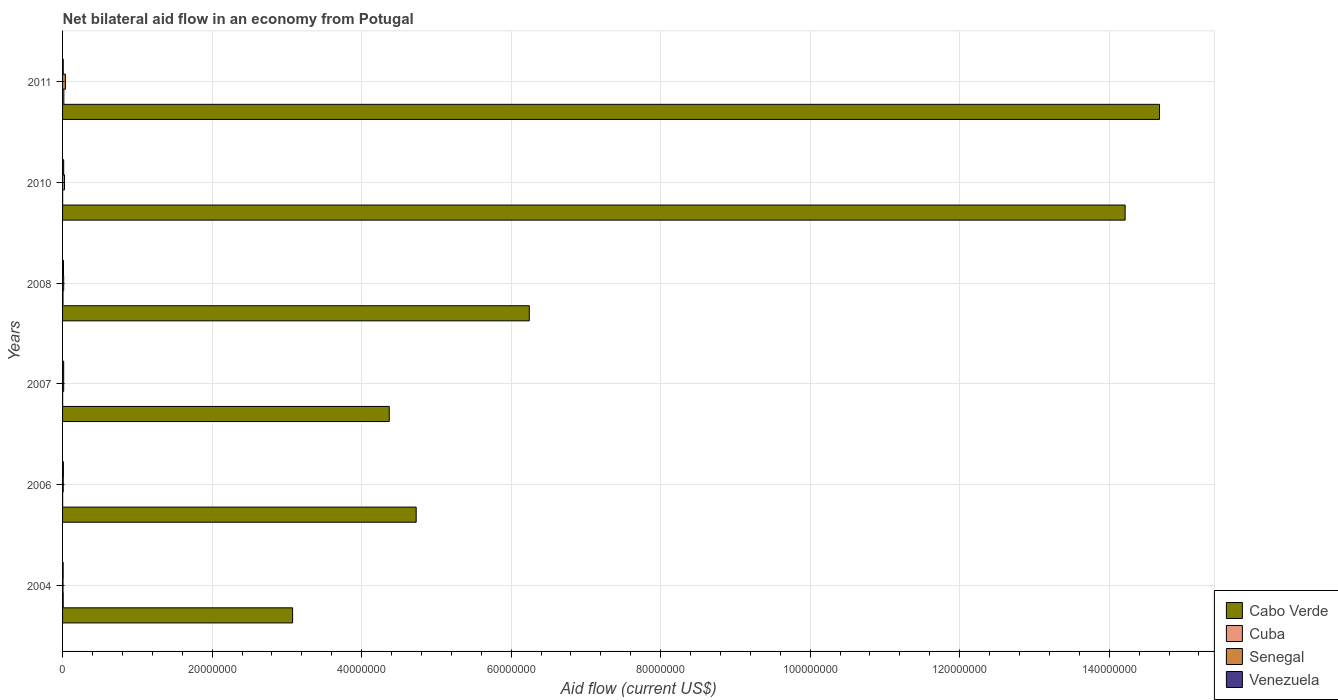Are the number of bars per tick equal to the number of legend labels?
Offer a very short reply. Yes. How many bars are there on the 5th tick from the bottom?
Your answer should be very brief. 4. What is the label of the 5th group of bars from the top?
Offer a terse response. 2006. Across all years, what is the minimum net bilateral aid flow in Cuba?
Offer a very short reply. 10000. What is the total net bilateral aid flow in Cabo Verde in the graph?
Offer a terse response. 4.73e+08. What is the difference between the net bilateral aid flow in Cabo Verde in 2011 and the net bilateral aid flow in Cuba in 2008?
Your answer should be compact. 1.47e+08. What is the average net bilateral aid flow in Cabo Verde per year?
Your response must be concise. 7.88e+07. In the year 2008, what is the difference between the net bilateral aid flow in Cabo Verde and net bilateral aid flow in Senegal?
Ensure brevity in your answer.  6.23e+07. What is the ratio of the net bilateral aid flow in Cuba in 2008 to that in 2011?
Your answer should be very brief. 0.35. What is the difference between the highest and the lowest net bilateral aid flow in Cabo Verde?
Offer a very short reply. 1.16e+08. Is it the case that in every year, the sum of the net bilateral aid flow in Senegal and net bilateral aid flow in Cuba is greater than the sum of net bilateral aid flow in Venezuela and net bilateral aid flow in Cabo Verde?
Make the answer very short. No. What does the 1st bar from the top in 2004 represents?
Give a very brief answer. Venezuela. What does the 3rd bar from the bottom in 2010 represents?
Ensure brevity in your answer.  Senegal. Are all the bars in the graph horizontal?
Provide a succinct answer. Yes. What is the difference between two consecutive major ticks on the X-axis?
Your answer should be very brief. 2.00e+07. Does the graph contain any zero values?
Offer a very short reply. No. Where does the legend appear in the graph?
Your answer should be very brief. Bottom right. What is the title of the graph?
Offer a very short reply. Net bilateral aid flow in an economy from Potugal. What is the label or title of the X-axis?
Your answer should be compact. Aid flow (current US$). What is the Aid flow (current US$) in Cabo Verde in 2004?
Ensure brevity in your answer.  3.08e+07. What is the Aid flow (current US$) of Cuba in 2004?
Offer a very short reply. 9.00e+04. What is the Aid flow (current US$) in Senegal in 2004?
Your response must be concise. 6.00e+04. What is the Aid flow (current US$) of Cabo Verde in 2006?
Offer a very short reply. 4.73e+07. What is the Aid flow (current US$) of Cabo Verde in 2007?
Offer a terse response. 4.37e+07. What is the Aid flow (current US$) of Cuba in 2007?
Provide a succinct answer. 10000. What is the Aid flow (current US$) of Senegal in 2007?
Ensure brevity in your answer.  1.50e+05. What is the Aid flow (current US$) in Cabo Verde in 2008?
Your answer should be compact. 6.24e+07. What is the Aid flow (current US$) in Cuba in 2008?
Your answer should be very brief. 6.00e+04. What is the Aid flow (current US$) in Venezuela in 2008?
Offer a very short reply. 1.20e+05. What is the Aid flow (current US$) in Cabo Verde in 2010?
Keep it short and to the point. 1.42e+08. What is the Aid flow (current US$) in Cuba in 2010?
Ensure brevity in your answer.  10000. What is the Aid flow (current US$) in Venezuela in 2010?
Give a very brief answer. 1.50e+05. What is the Aid flow (current US$) in Cabo Verde in 2011?
Offer a very short reply. 1.47e+08. What is the Aid flow (current US$) in Cuba in 2011?
Keep it short and to the point. 1.70e+05. What is the Aid flow (current US$) in Senegal in 2011?
Provide a succinct answer. 3.80e+05. Across all years, what is the maximum Aid flow (current US$) in Cabo Verde?
Give a very brief answer. 1.47e+08. Across all years, what is the maximum Aid flow (current US$) in Cuba?
Your answer should be compact. 1.70e+05. Across all years, what is the maximum Aid flow (current US$) of Senegal?
Your answer should be very brief. 3.80e+05. Across all years, what is the maximum Aid flow (current US$) of Venezuela?
Your response must be concise. 1.50e+05. Across all years, what is the minimum Aid flow (current US$) in Cabo Verde?
Make the answer very short. 3.08e+07. Across all years, what is the minimum Aid flow (current US$) of Senegal?
Your answer should be very brief. 6.00e+04. What is the total Aid flow (current US$) of Cabo Verde in the graph?
Provide a succinct answer. 4.73e+08. What is the total Aid flow (current US$) in Senegal in the graph?
Keep it short and to the point. 1.09e+06. What is the total Aid flow (current US$) of Venezuela in the graph?
Provide a short and direct response. 7.00e+05. What is the difference between the Aid flow (current US$) of Cabo Verde in 2004 and that in 2006?
Your answer should be very brief. -1.65e+07. What is the difference between the Aid flow (current US$) of Venezuela in 2004 and that in 2006?
Ensure brevity in your answer.  -3.00e+04. What is the difference between the Aid flow (current US$) in Cabo Verde in 2004 and that in 2007?
Offer a terse response. -1.29e+07. What is the difference between the Aid flow (current US$) of Venezuela in 2004 and that in 2007?
Provide a short and direct response. -7.00e+04. What is the difference between the Aid flow (current US$) of Cabo Verde in 2004 and that in 2008?
Your answer should be very brief. -3.17e+07. What is the difference between the Aid flow (current US$) in Cabo Verde in 2004 and that in 2010?
Offer a terse response. -1.11e+08. What is the difference between the Aid flow (current US$) in Cuba in 2004 and that in 2010?
Provide a short and direct response. 8.00e+04. What is the difference between the Aid flow (current US$) of Senegal in 2004 and that in 2010?
Provide a succinct answer. -2.00e+05. What is the difference between the Aid flow (current US$) in Venezuela in 2004 and that in 2010?
Offer a very short reply. -7.00e+04. What is the difference between the Aid flow (current US$) of Cabo Verde in 2004 and that in 2011?
Give a very brief answer. -1.16e+08. What is the difference between the Aid flow (current US$) in Senegal in 2004 and that in 2011?
Give a very brief answer. -3.20e+05. What is the difference between the Aid flow (current US$) in Venezuela in 2004 and that in 2011?
Provide a short and direct response. -10000. What is the difference between the Aid flow (current US$) of Cabo Verde in 2006 and that in 2007?
Provide a short and direct response. 3.60e+06. What is the difference between the Aid flow (current US$) of Senegal in 2006 and that in 2007?
Offer a very short reply. -6.00e+04. What is the difference between the Aid flow (current US$) of Cabo Verde in 2006 and that in 2008?
Give a very brief answer. -1.51e+07. What is the difference between the Aid flow (current US$) in Venezuela in 2006 and that in 2008?
Ensure brevity in your answer.  -10000. What is the difference between the Aid flow (current US$) in Cabo Verde in 2006 and that in 2010?
Offer a very short reply. -9.48e+07. What is the difference between the Aid flow (current US$) in Senegal in 2006 and that in 2010?
Ensure brevity in your answer.  -1.70e+05. What is the difference between the Aid flow (current US$) of Cabo Verde in 2006 and that in 2011?
Your answer should be very brief. -9.94e+07. What is the difference between the Aid flow (current US$) in Cuba in 2006 and that in 2011?
Ensure brevity in your answer.  -1.60e+05. What is the difference between the Aid flow (current US$) of Venezuela in 2006 and that in 2011?
Ensure brevity in your answer.  2.00e+04. What is the difference between the Aid flow (current US$) of Cabo Verde in 2007 and that in 2008?
Make the answer very short. -1.87e+07. What is the difference between the Aid flow (current US$) of Senegal in 2007 and that in 2008?
Offer a very short reply. 0. What is the difference between the Aid flow (current US$) in Cabo Verde in 2007 and that in 2010?
Provide a succinct answer. -9.84e+07. What is the difference between the Aid flow (current US$) of Cuba in 2007 and that in 2010?
Ensure brevity in your answer.  0. What is the difference between the Aid flow (current US$) in Senegal in 2007 and that in 2010?
Your response must be concise. -1.10e+05. What is the difference between the Aid flow (current US$) in Cabo Verde in 2007 and that in 2011?
Provide a short and direct response. -1.03e+08. What is the difference between the Aid flow (current US$) in Cuba in 2007 and that in 2011?
Give a very brief answer. -1.60e+05. What is the difference between the Aid flow (current US$) of Senegal in 2007 and that in 2011?
Keep it short and to the point. -2.30e+05. What is the difference between the Aid flow (current US$) of Venezuela in 2007 and that in 2011?
Offer a terse response. 6.00e+04. What is the difference between the Aid flow (current US$) of Cabo Verde in 2008 and that in 2010?
Your answer should be very brief. -7.97e+07. What is the difference between the Aid flow (current US$) in Venezuela in 2008 and that in 2010?
Provide a short and direct response. -3.00e+04. What is the difference between the Aid flow (current US$) of Cabo Verde in 2008 and that in 2011?
Give a very brief answer. -8.43e+07. What is the difference between the Aid flow (current US$) of Cuba in 2008 and that in 2011?
Offer a very short reply. -1.10e+05. What is the difference between the Aid flow (current US$) of Cabo Verde in 2010 and that in 2011?
Ensure brevity in your answer.  -4.60e+06. What is the difference between the Aid flow (current US$) in Cuba in 2010 and that in 2011?
Your answer should be compact. -1.60e+05. What is the difference between the Aid flow (current US$) of Venezuela in 2010 and that in 2011?
Ensure brevity in your answer.  6.00e+04. What is the difference between the Aid flow (current US$) of Cabo Verde in 2004 and the Aid flow (current US$) of Cuba in 2006?
Your response must be concise. 3.08e+07. What is the difference between the Aid flow (current US$) in Cabo Verde in 2004 and the Aid flow (current US$) in Senegal in 2006?
Provide a succinct answer. 3.07e+07. What is the difference between the Aid flow (current US$) in Cabo Verde in 2004 and the Aid flow (current US$) in Venezuela in 2006?
Give a very brief answer. 3.07e+07. What is the difference between the Aid flow (current US$) of Cuba in 2004 and the Aid flow (current US$) of Senegal in 2006?
Provide a short and direct response. 0. What is the difference between the Aid flow (current US$) in Senegal in 2004 and the Aid flow (current US$) in Venezuela in 2006?
Give a very brief answer. -5.00e+04. What is the difference between the Aid flow (current US$) of Cabo Verde in 2004 and the Aid flow (current US$) of Cuba in 2007?
Provide a succinct answer. 3.08e+07. What is the difference between the Aid flow (current US$) of Cabo Verde in 2004 and the Aid flow (current US$) of Senegal in 2007?
Your response must be concise. 3.06e+07. What is the difference between the Aid flow (current US$) of Cabo Verde in 2004 and the Aid flow (current US$) of Venezuela in 2007?
Your response must be concise. 3.06e+07. What is the difference between the Aid flow (current US$) of Cuba in 2004 and the Aid flow (current US$) of Senegal in 2007?
Provide a short and direct response. -6.00e+04. What is the difference between the Aid flow (current US$) of Senegal in 2004 and the Aid flow (current US$) of Venezuela in 2007?
Provide a succinct answer. -9.00e+04. What is the difference between the Aid flow (current US$) of Cabo Verde in 2004 and the Aid flow (current US$) of Cuba in 2008?
Your answer should be compact. 3.07e+07. What is the difference between the Aid flow (current US$) of Cabo Verde in 2004 and the Aid flow (current US$) of Senegal in 2008?
Ensure brevity in your answer.  3.06e+07. What is the difference between the Aid flow (current US$) of Cabo Verde in 2004 and the Aid flow (current US$) of Venezuela in 2008?
Ensure brevity in your answer.  3.06e+07. What is the difference between the Aid flow (current US$) of Cuba in 2004 and the Aid flow (current US$) of Venezuela in 2008?
Keep it short and to the point. -3.00e+04. What is the difference between the Aid flow (current US$) of Senegal in 2004 and the Aid flow (current US$) of Venezuela in 2008?
Offer a terse response. -6.00e+04. What is the difference between the Aid flow (current US$) in Cabo Verde in 2004 and the Aid flow (current US$) in Cuba in 2010?
Your response must be concise. 3.08e+07. What is the difference between the Aid flow (current US$) of Cabo Verde in 2004 and the Aid flow (current US$) of Senegal in 2010?
Provide a short and direct response. 3.05e+07. What is the difference between the Aid flow (current US$) of Cabo Verde in 2004 and the Aid flow (current US$) of Venezuela in 2010?
Give a very brief answer. 3.06e+07. What is the difference between the Aid flow (current US$) in Cuba in 2004 and the Aid flow (current US$) in Senegal in 2010?
Provide a short and direct response. -1.70e+05. What is the difference between the Aid flow (current US$) of Senegal in 2004 and the Aid flow (current US$) of Venezuela in 2010?
Make the answer very short. -9.00e+04. What is the difference between the Aid flow (current US$) in Cabo Verde in 2004 and the Aid flow (current US$) in Cuba in 2011?
Offer a very short reply. 3.06e+07. What is the difference between the Aid flow (current US$) in Cabo Verde in 2004 and the Aid flow (current US$) in Senegal in 2011?
Your answer should be compact. 3.04e+07. What is the difference between the Aid flow (current US$) of Cabo Verde in 2004 and the Aid flow (current US$) of Venezuela in 2011?
Provide a short and direct response. 3.07e+07. What is the difference between the Aid flow (current US$) in Cuba in 2004 and the Aid flow (current US$) in Senegal in 2011?
Give a very brief answer. -2.90e+05. What is the difference between the Aid flow (current US$) in Cabo Verde in 2006 and the Aid flow (current US$) in Cuba in 2007?
Your answer should be very brief. 4.73e+07. What is the difference between the Aid flow (current US$) of Cabo Verde in 2006 and the Aid flow (current US$) of Senegal in 2007?
Your answer should be compact. 4.72e+07. What is the difference between the Aid flow (current US$) in Cabo Verde in 2006 and the Aid flow (current US$) in Venezuela in 2007?
Give a very brief answer. 4.72e+07. What is the difference between the Aid flow (current US$) in Cuba in 2006 and the Aid flow (current US$) in Venezuela in 2007?
Make the answer very short. -1.40e+05. What is the difference between the Aid flow (current US$) in Cabo Verde in 2006 and the Aid flow (current US$) in Cuba in 2008?
Provide a succinct answer. 4.72e+07. What is the difference between the Aid flow (current US$) of Cabo Verde in 2006 and the Aid flow (current US$) of Senegal in 2008?
Provide a short and direct response. 4.72e+07. What is the difference between the Aid flow (current US$) in Cabo Verde in 2006 and the Aid flow (current US$) in Venezuela in 2008?
Your response must be concise. 4.72e+07. What is the difference between the Aid flow (current US$) of Cabo Verde in 2006 and the Aid flow (current US$) of Cuba in 2010?
Keep it short and to the point. 4.73e+07. What is the difference between the Aid flow (current US$) in Cabo Verde in 2006 and the Aid flow (current US$) in Senegal in 2010?
Keep it short and to the point. 4.70e+07. What is the difference between the Aid flow (current US$) of Cabo Verde in 2006 and the Aid flow (current US$) of Venezuela in 2010?
Provide a succinct answer. 4.72e+07. What is the difference between the Aid flow (current US$) of Cuba in 2006 and the Aid flow (current US$) of Senegal in 2010?
Ensure brevity in your answer.  -2.50e+05. What is the difference between the Aid flow (current US$) of Cuba in 2006 and the Aid flow (current US$) of Venezuela in 2010?
Give a very brief answer. -1.40e+05. What is the difference between the Aid flow (current US$) in Cabo Verde in 2006 and the Aid flow (current US$) in Cuba in 2011?
Keep it short and to the point. 4.71e+07. What is the difference between the Aid flow (current US$) of Cabo Verde in 2006 and the Aid flow (current US$) of Senegal in 2011?
Your response must be concise. 4.69e+07. What is the difference between the Aid flow (current US$) in Cabo Verde in 2006 and the Aid flow (current US$) in Venezuela in 2011?
Provide a succinct answer. 4.72e+07. What is the difference between the Aid flow (current US$) in Cuba in 2006 and the Aid flow (current US$) in Senegal in 2011?
Your answer should be compact. -3.70e+05. What is the difference between the Aid flow (current US$) of Cuba in 2006 and the Aid flow (current US$) of Venezuela in 2011?
Provide a succinct answer. -8.00e+04. What is the difference between the Aid flow (current US$) of Cabo Verde in 2007 and the Aid flow (current US$) of Cuba in 2008?
Provide a succinct answer. 4.36e+07. What is the difference between the Aid flow (current US$) of Cabo Verde in 2007 and the Aid flow (current US$) of Senegal in 2008?
Your answer should be very brief. 4.36e+07. What is the difference between the Aid flow (current US$) in Cabo Verde in 2007 and the Aid flow (current US$) in Venezuela in 2008?
Ensure brevity in your answer.  4.36e+07. What is the difference between the Aid flow (current US$) in Cuba in 2007 and the Aid flow (current US$) in Senegal in 2008?
Your answer should be very brief. -1.40e+05. What is the difference between the Aid flow (current US$) in Senegal in 2007 and the Aid flow (current US$) in Venezuela in 2008?
Your answer should be compact. 3.00e+04. What is the difference between the Aid flow (current US$) in Cabo Verde in 2007 and the Aid flow (current US$) in Cuba in 2010?
Keep it short and to the point. 4.37e+07. What is the difference between the Aid flow (current US$) of Cabo Verde in 2007 and the Aid flow (current US$) of Senegal in 2010?
Your answer should be very brief. 4.34e+07. What is the difference between the Aid flow (current US$) of Cabo Verde in 2007 and the Aid flow (current US$) of Venezuela in 2010?
Offer a terse response. 4.36e+07. What is the difference between the Aid flow (current US$) in Cuba in 2007 and the Aid flow (current US$) in Venezuela in 2010?
Your response must be concise. -1.40e+05. What is the difference between the Aid flow (current US$) of Senegal in 2007 and the Aid flow (current US$) of Venezuela in 2010?
Your answer should be very brief. 0. What is the difference between the Aid flow (current US$) in Cabo Verde in 2007 and the Aid flow (current US$) in Cuba in 2011?
Keep it short and to the point. 4.35e+07. What is the difference between the Aid flow (current US$) in Cabo Verde in 2007 and the Aid flow (current US$) in Senegal in 2011?
Your answer should be compact. 4.33e+07. What is the difference between the Aid flow (current US$) in Cabo Verde in 2007 and the Aid flow (current US$) in Venezuela in 2011?
Keep it short and to the point. 4.36e+07. What is the difference between the Aid flow (current US$) of Cuba in 2007 and the Aid flow (current US$) of Senegal in 2011?
Offer a terse response. -3.70e+05. What is the difference between the Aid flow (current US$) of Cabo Verde in 2008 and the Aid flow (current US$) of Cuba in 2010?
Make the answer very short. 6.24e+07. What is the difference between the Aid flow (current US$) in Cabo Verde in 2008 and the Aid flow (current US$) in Senegal in 2010?
Keep it short and to the point. 6.22e+07. What is the difference between the Aid flow (current US$) of Cabo Verde in 2008 and the Aid flow (current US$) of Venezuela in 2010?
Your response must be concise. 6.23e+07. What is the difference between the Aid flow (current US$) of Senegal in 2008 and the Aid flow (current US$) of Venezuela in 2010?
Your answer should be very brief. 0. What is the difference between the Aid flow (current US$) of Cabo Verde in 2008 and the Aid flow (current US$) of Cuba in 2011?
Keep it short and to the point. 6.23e+07. What is the difference between the Aid flow (current US$) in Cabo Verde in 2008 and the Aid flow (current US$) in Senegal in 2011?
Ensure brevity in your answer.  6.20e+07. What is the difference between the Aid flow (current US$) in Cabo Verde in 2008 and the Aid flow (current US$) in Venezuela in 2011?
Keep it short and to the point. 6.23e+07. What is the difference between the Aid flow (current US$) of Cuba in 2008 and the Aid flow (current US$) of Senegal in 2011?
Provide a succinct answer. -3.20e+05. What is the difference between the Aid flow (current US$) in Cuba in 2008 and the Aid flow (current US$) in Venezuela in 2011?
Make the answer very short. -3.00e+04. What is the difference between the Aid flow (current US$) in Cabo Verde in 2010 and the Aid flow (current US$) in Cuba in 2011?
Your answer should be very brief. 1.42e+08. What is the difference between the Aid flow (current US$) of Cabo Verde in 2010 and the Aid flow (current US$) of Senegal in 2011?
Provide a short and direct response. 1.42e+08. What is the difference between the Aid flow (current US$) in Cabo Verde in 2010 and the Aid flow (current US$) in Venezuela in 2011?
Provide a succinct answer. 1.42e+08. What is the difference between the Aid flow (current US$) in Cuba in 2010 and the Aid flow (current US$) in Senegal in 2011?
Give a very brief answer. -3.70e+05. What is the average Aid flow (current US$) in Cabo Verde per year?
Keep it short and to the point. 7.88e+07. What is the average Aid flow (current US$) of Cuba per year?
Offer a very short reply. 5.83e+04. What is the average Aid flow (current US$) in Senegal per year?
Your response must be concise. 1.82e+05. What is the average Aid flow (current US$) of Venezuela per year?
Your response must be concise. 1.17e+05. In the year 2004, what is the difference between the Aid flow (current US$) in Cabo Verde and Aid flow (current US$) in Cuba?
Your answer should be compact. 3.07e+07. In the year 2004, what is the difference between the Aid flow (current US$) of Cabo Verde and Aid flow (current US$) of Senegal?
Give a very brief answer. 3.07e+07. In the year 2004, what is the difference between the Aid flow (current US$) of Cabo Verde and Aid flow (current US$) of Venezuela?
Make the answer very short. 3.07e+07. In the year 2004, what is the difference between the Aid flow (current US$) in Cuba and Aid flow (current US$) in Venezuela?
Offer a terse response. 10000. In the year 2006, what is the difference between the Aid flow (current US$) of Cabo Verde and Aid flow (current US$) of Cuba?
Make the answer very short. 4.73e+07. In the year 2006, what is the difference between the Aid flow (current US$) of Cabo Verde and Aid flow (current US$) of Senegal?
Your response must be concise. 4.72e+07. In the year 2006, what is the difference between the Aid flow (current US$) of Cabo Verde and Aid flow (current US$) of Venezuela?
Keep it short and to the point. 4.72e+07. In the year 2006, what is the difference between the Aid flow (current US$) of Cuba and Aid flow (current US$) of Senegal?
Offer a terse response. -8.00e+04. In the year 2006, what is the difference between the Aid flow (current US$) in Cuba and Aid flow (current US$) in Venezuela?
Give a very brief answer. -1.00e+05. In the year 2007, what is the difference between the Aid flow (current US$) of Cabo Verde and Aid flow (current US$) of Cuba?
Your answer should be very brief. 4.37e+07. In the year 2007, what is the difference between the Aid flow (current US$) of Cabo Verde and Aid flow (current US$) of Senegal?
Make the answer very short. 4.36e+07. In the year 2007, what is the difference between the Aid flow (current US$) of Cabo Verde and Aid flow (current US$) of Venezuela?
Provide a short and direct response. 4.36e+07. In the year 2008, what is the difference between the Aid flow (current US$) of Cabo Verde and Aid flow (current US$) of Cuba?
Provide a short and direct response. 6.24e+07. In the year 2008, what is the difference between the Aid flow (current US$) of Cabo Verde and Aid flow (current US$) of Senegal?
Offer a very short reply. 6.23e+07. In the year 2008, what is the difference between the Aid flow (current US$) in Cabo Verde and Aid flow (current US$) in Venezuela?
Make the answer very short. 6.23e+07. In the year 2008, what is the difference between the Aid flow (current US$) in Cuba and Aid flow (current US$) in Venezuela?
Offer a terse response. -6.00e+04. In the year 2010, what is the difference between the Aid flow (current US$) of Cabo Verde and Aid flow (current US$) of Cuba?
Your answer should be very brief. 1.42e+08. In the year 2010, what is the difference between the Aid flow (current US$) in Cabo Verde and Aid flow (current US$) in Senegal?
Your answer should be very brief. 1.42e+08. In the year 2010, what is the difference between the Aid flow (current US$) of Cabo Verde and Aid flow (current US$) of Venezuela?
Your response must be concise. 1.42e+08. In the year 2010, what is the difference between the Aid flow (current US$) of Cuba and Aid flow (current US$) of Senegal?
Give a very brief answer. -2.50e+05. In the year 2011, what is the difference between the Aid flow (current US$) of Cabo Verde and Aid flow (current US$) of Cuba?
Provide a short and direct response. 1.47e+08. In the year 2011, what is the difference between the Aid flow (current US$) in Cabo Verde and Aid flow (current US$) in Senegal?
Offer a very short reply. 1.46e+08. In the year 2011, what is the difference between the Aid flow (current US$) in Cabo Verde and Aid flow (current US$) in Venezuela?
Offer a very short reply. 1.47e+08. In the year 2011, what is the difference between the Aid flow (current US$) of Cuba and Aid flow (current US$) of Senegal?
Your answer should be compact. -2.10e+05. What is the ratio of the Aid flow (current US$) of Cabo Verde in 2004 to that in 2006?
Offer a very short reply. 0.65. What is the ratio of the Aid flow (current US$) of Cuba in 2004 to that in 2006?
Your answer should be very brief. 9. What is the ratio of the Aid flow (current US$) in Venezuela in 2004 to that in 2006?
Offer a terse response. 0.73. What is the ratio of the Aid flow (current US$) of Cabo Verde in 2004 to that in 2007?
Offer a very short reply. 0.7. What is the ratio of the Aid flow (current US$) in Senegal in 2004 to that in 2007?
Your response must be concise. 0.4. What is the ratio of the Aid flow (current US$) in Venezuela in 2004 to that in 2007?
Your answer should be very brief. 0.53. What is the ratio of the Aid flow (current US$) in Cabo Verde in 2004 to that in 2008?
Make the answer very short. 0.49. What is the ratio of the Aid flow (current US$) in Cuba in 2004 to that in 2008?
Your response must be concise. 1.5. What is the ratio of the Aid flow (current US$) in Cabo Verde in 2004 to that in 2010?
Ensure brevity in your answer.  0.22. What is the ratio of the Aid flow (current US$) of Senegal in 2004 to that in 2010?
Make the answer very short. 0.23. What is the ratio of the Aid flow (current US$) of Venezuela in 2004 to that in 2010?
Make the answer very short. 0.53. What is the ratio of the Aid flow (current US$) in Cabo Verde in 2004 to that in 2011?
Your response must be concise. 0.21. What is the ratio of the Aid flow (current US$) in Cuba in 2004 to that in 2011?
Offer a terse response. 0.53. What is the ratio of the Aid flow (current US$) of Senegal in 2004 to that in 2011?
Make the answer very short. 0.16. What is the ratio of the Aid flow (current US$) in Venezuela in 2004 to that in 2011?
Make the answer very short. 0.89. What is the ratio of the Aid flow (current US$) in Cabo Verde in 2006 to that in 2007?
Provide a succinct answer. 1.08. What is the ratio of the Aid flow (current US$) of Venezuela in 2006 to that in 2007?
Your response must be concise. 0.73. What is the ratio of the Aid flow (current US$) in Cabo Verde in 2006 to that in 2008?
Your response must be concise. 0.76. What is the ratio of the Aid flow (current US$) of Cabo Verde in 2006 to that in 2010?
Give a very brief answer. 0.33. What is the ratio of the Aid flow (current US$) of Cuba in 2006 to that in 2010?
Your response must be concise. 1. What is the ratio of the Aid flow (current US$) of Senegal in 2006 to that in 2010?
Offer a very short reply. 0.35. What is the ratio of the Aid flow (current US$) in Venezuela in 2006 to that in 2010?
Your answer should be very brief. 0.73. What is the ratio of the Aid flow (current US$) in Cabo Verde in 2006 to that in 2011?
Provide a succinct answer. 0.32. What is the ratio of the Aid flow (current US$) in Cuba in 2006 to that in 2011?
Your response must be concise. 0.06. What is the ratio of the Aid flow (current US$) in Senegal in 2006 to that in 2011?
Ensure brevity in your answer.  0.24. What is the ratio of the Aid flow (current US$) in Venezuela in 2006 to that in 2011?
Provide a succinct answer. 1.22. What is the ratio of the Aid flow (current US$) in Cuba in 2007 to that in 2008?
Your answer should be compact. 0.17. What is the ratio of the Aid flow (current US$) in Senegal in 2007 to that in 2008?
Provide a short and direct response. 1. What is the ratio of the Aid flow (current US$) in Cabo Verde in 2007 to that in 2010?
Give a very brief answer. 0.31. What is the ratio of the Aid flow (current US$) of Cuba in 2007 to that in 2010?
Keep it short and to the point. 1. What is the ratio of the Aid flow (current US$) of Senegal in 2007 to that in 2010?
Give a very brief answer. 0.58. What is the ratio of the Aid flow (current US$) in Venezuela in 2007 to that in 2010?
Your answer should be very brief. 1. What is the ratio of the Aid flow (current US$) in Cabo Verde in 2007 to that in 2011?
Offer a terse response. 0.3. What is the ratio of the Aid flow (current US$) in Cuba in 2007 to that in 2011?
Ensure brevity in your answer.  0.06. What is the ratio of the Aid flow (current US$) in Senegal in 2007 to that in 2011?
Your response must be concise. 0.39. What is the ratio of the Aid flow (current US$) in Cabo Verde in 2008 to that in 2010?
Your answer should be compact. 0.44. What is the ratio of the Aid flow (current US$) of Senegal in 2008 to that in 2010?
Make the answer very short. 0.58. What is the ratio of the Aid flow (current US$) in Venezuela in 2008 to that in 2010?
Offer a terse response. 0.8. What is the ratio of the Aid flow (current US$) in Cabo Verde in 2008 to that in 2011?
Your answer should be compact. 0.43. What is the ratio of the Aid flow (current US$) in Cuba in 2008 to that in 2011?
Your response must be concise. 0.35. What is the ratio of the Aid flow (current US$) of Senegal in 2008 to that in 2011?
Your answer should be very brief. 0.39. What is the ratio of the Aid flow (current US$) of Cabo Verde in 2010 to that in 2011?
Your answer should be compact. 0.97. What is the ratio of the Aid flow (current US$) of Cuba in 2010 to that in 2011?
Your answer should be compact. 0.06. What is the ratio of the Aid flow (current US$) of Senegal in 2010 to that in 2011?
Your answer should be very brief. 0.68. What is the ratio of the Aid flow (current US$) in Venezuela in 2010 to that in 2011?
Provide a succinct answer. 1.67. What is the difference between the highest and the second highest Aid flow (current US$) in Cabo Verde?
Provide a succinct answer. 4.60e+06. What is the difference between the highest and the second highest Aid flow (current US$) of Cuba?
Your response must be concise. 8.00e+04. What is the difference between the highest and the second highest Aid flow (current US$) in Senegal?
Offer a terse response. 1.20e+05. What is the difference between the highest and the second highest Aid flow (current US$) in Venezuela?
Your response must be concise. 0. What is the difference between the highest and the lowest Aid flow (current US$) in Cabo Verde?
Your answer should be compact. 1.16e+08. What is the difference between the highest and the lowest Aid flow (current US$) in Senegal?
Give a very brief answer. 3.20e+05. What is the difference between the highest and the lowest Aid flow (current US$) in Venezuela?
Provide a succinct answer. 7.00e+04. 